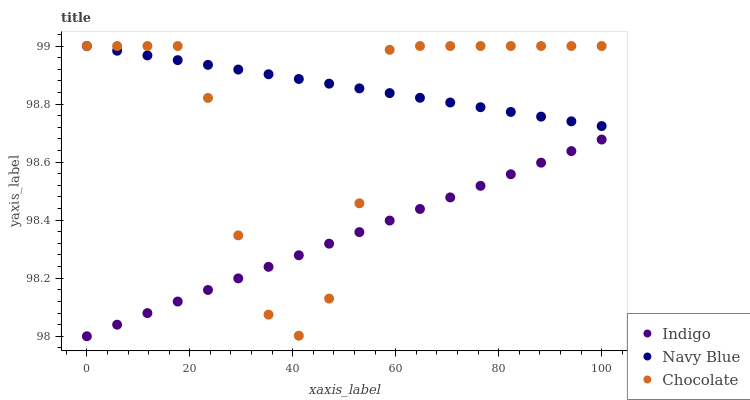Does Indigo have the minimum area under the curve?
Answer yes or no. Yes. Does Navy Blue have the maximum area under the curve?
Answer yes or no. Yes. Does Chocolate have the minimum area under the curve?
Answer yes or no. No. Does Chocolate have the maximum area under the curve?
Answer yes or no. No. Is Navy Blue the smoothest?
Answer yes or no. Yes. Is Chocolate the roughest?
Answer yes or no. Yes. Is Indigo the smoothest?
Answer yes or no. No. Is Indigo the roughest?
Answer yes or no. No. Does Indigo have the lowest value?
Answer yes or no. Yes. Does Chocolate have the lowest value?
Answer yes or no. No. Does Chocolate have the highest value?
Answer yes or no. Yes. Does Indigo have the highest value?
Answer yes or no. No. Is Indigo less than Navy Blue?
Answer yes or no. Yes. Is Navy Blue greater than Indigo?
Answer yes or no. Yes. Does Chocolate intersect Indigo?
Answer yes or no. Yes. Is Chocolate less than Indigo?
Answer yes or no. No. Is Chocolate greater than Indigo?
Answer yes or no. No. Does Indigo intersect Navy Blue?
Answer yes or no. No. 